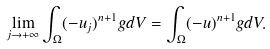Convert formula to latex. <formula><loc_0><loc_0><loc_500><loc_500>\lim _ { j \to + \infty } \int _ { \Omega } ( - u _ { j } ) ^ { n + 1 } g d V = \int _ { \Omega } ( - u ) ^ { n + 1 } g d V .</formula> 